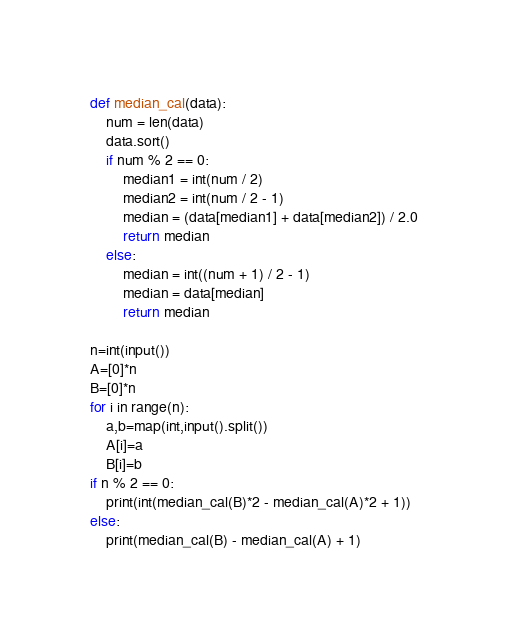<code> <loc_0><loc_0><loc_500><loc_500><_Python_>def median_cal(data):
    num = len(data)
    data.sort()
    if num % 2 == 0:
        median1 = int(num / 2)
        median2 = int(num / 2 - 1)
        median = (data[median1] + data[median2]) / 2.0
        return median
    else:
        median = int((num + 1) / 2 - 1)
        median = data[median]
        return median

n=int(input())
A=[0]*n
B=[0]*n
for i in range(n):
    a,b=map(int,input().split())
    A[i]=a
    B[i]=b
if n % 2 == 0:
    print(int(median_cal(B)*2 - median_cal(A)*2 + 1))
else:
    print(median_cal(B) - median_cal(A) + 1)</code> 